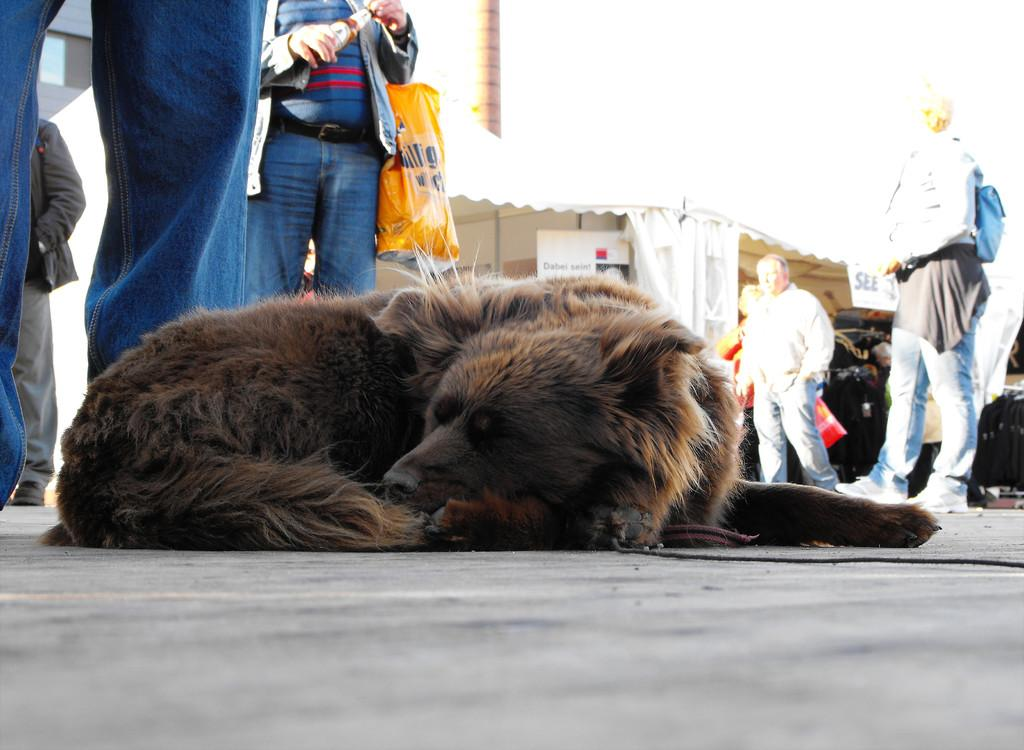What is the main subject on the left side of the image? There is a dog lying on a road on the left side of the image. What can be seen in the background of the image? There are other persons, shelters, a tower, clouds in the sky, and other objects in the background of the image. How many spiders are crawling on the dog in the image? There are no spiders present in the image; the main subject is a dog lying on a road. 